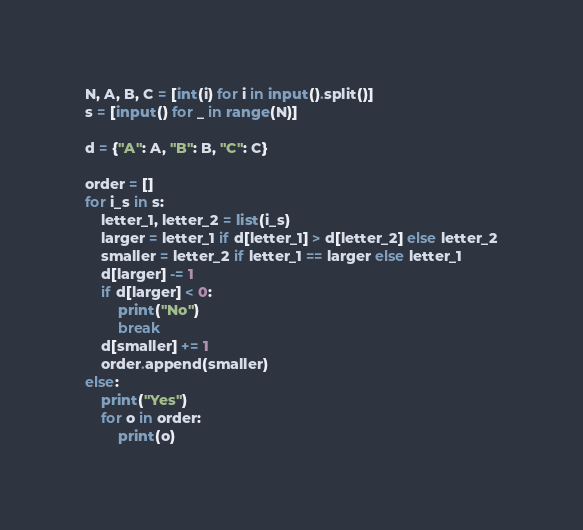<code> <loc_0><loc_0><loc_500><loc_500><_Python_>N, A, B, C = [int(i) for i in input().split()]
s = [input() for _ in range(N)]

d = {"A": A, "B": B, "C": C}

order = []
for i_s in s:
    letter_1, letter_2 = list(i_s)
    larger = letter_1 if d[letter_1] > d[letter_2] else letter_2
    smaller = letter_2 if letter_1 == larger else letter_1
    d[larger] -= 1
    if d[larger] < 0:
        print("No")
        break
    d[smaller] += 1
    order.append(smaller)
else:
    print("Yes")
    for o in order:
        print(o)
</code> 